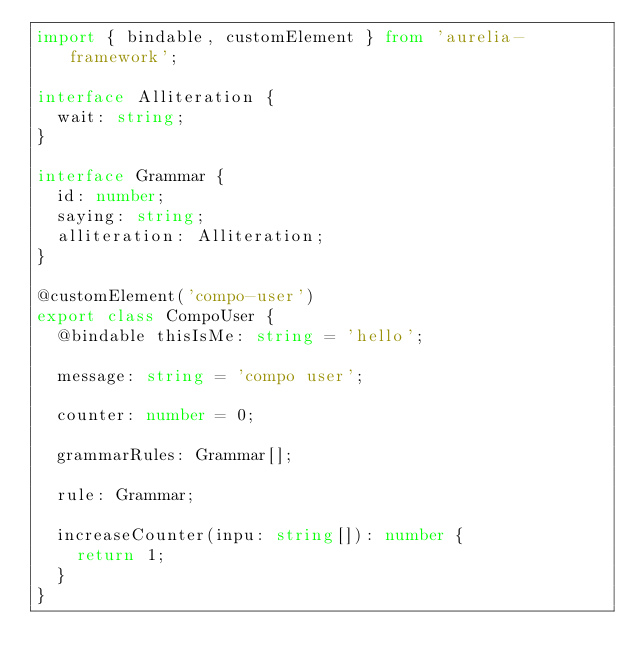Convert code to text. <code><loc_0><loc_0><loc_500><loc_500><_TypeScript_>import { bindable, customElement } from 'aurelia-framework';

interface Alliteration {
  wait: string;
}

interface Grammar {
  id: number;
  saying: string;
  alliteration: Alliteration;
}

@customElement('compo-user')
export class CompoUser {
  @bindable thisIsMe: string = 'hello';

  message: string = 'compo user';

  counter: number = 0;

  grammarRules: Grammar[];

  rule: Grammar;

  increaseCounter(inpu: string[]): number {
    return 1;
  }
}
</code> 